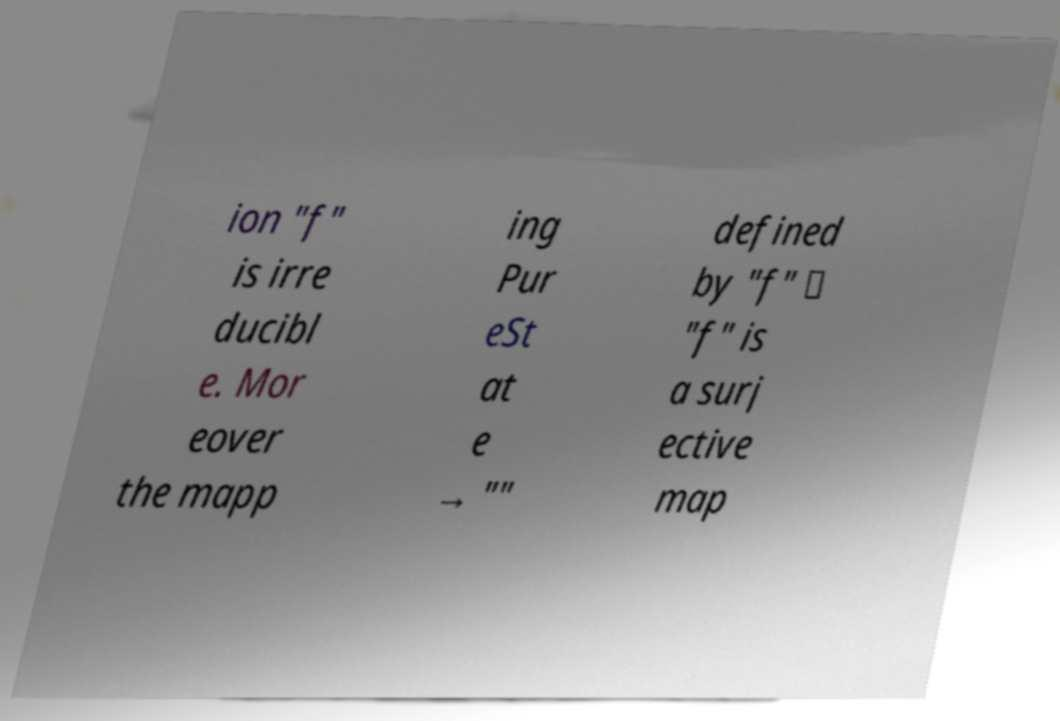There's text embedded in this image that I need extracted. Can you transcribe it verbatim? ion "f" is irre ducibl e. Mor eover the mapp ing Pur eSt at e → "" defined by "f" ↦ "f" is a surj ective map 